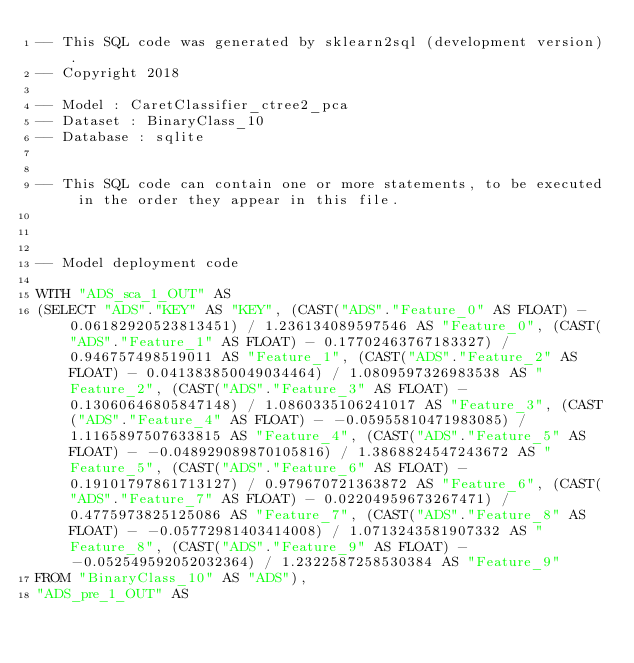Convert code to text. <code><loc_0><loc_0><loc_500><loc_500><_SQL_>-- This SQL code was generated by sklearn2sql (development version).
-- Copyright 2018

-- Model : CaretClassifier_ctree2_pca
-- Dataset : BinaryClass_10
-- Database : sqlite


-- This SQL code can contain one or more statements, to be executed in the order they appear in this file.



-- Model deployment code

WITH "ADS_sca_1_OUT" AS 
(SELECT "ADS"."KEY" AS "KEY", (CAST("ADS"."Feature_0" AS FLOAT) - 0.06182920523813451) / 1.236134089597546 AS "Feature_0", (CAST("ADS"."Feature_1" AS FLOAT) - 0.17702463767183327) / 0.946757498519011 AS "Feature_1", (CAST("ADS"."Feature_2" AS FLOAT) - 0.041383850049034464) / 1.0809597326983538 AS "Feature_2", (CAST("ADS"."Feature_3" AS FLOAT) - 0.13060646805847148) / 1.0860335106241017 AS "Feature_3", (CAST("ADS"."Feature_4" AS FLOAT) - -0.05955810471983085) / 1.1165897507633815 AS "Feature_4", (CAST("ADS"."Feature_5" AS FLOAT) - -0.048929089870105816) / 1.3868824547243672 AS "Feature_5", (CAST("ADS"."Feature_6" AS FLOAT) - 0.19101797861713127) / 0.979670721363872 AS "Feature_6", (CAST("ADS"."Feature_7" AS FLOAT) - 0.02204959673267471) / 0.4775973825125086 AS "Feature_7", (CAST("ADS"."Feature_8" AS FLOAT) - -0.05772981403414008) / 1.0713243581907332 AS "Feature_8", (CAST("ADS"."Feature_9" AS FLOAT) - -0.052549592052032364) / 1.2322587258530384 AS "Feature_9" 
FROM "BinaryClass_10" AS "ADS"), 
"ADS_pre_1_OUT" AS </code> 